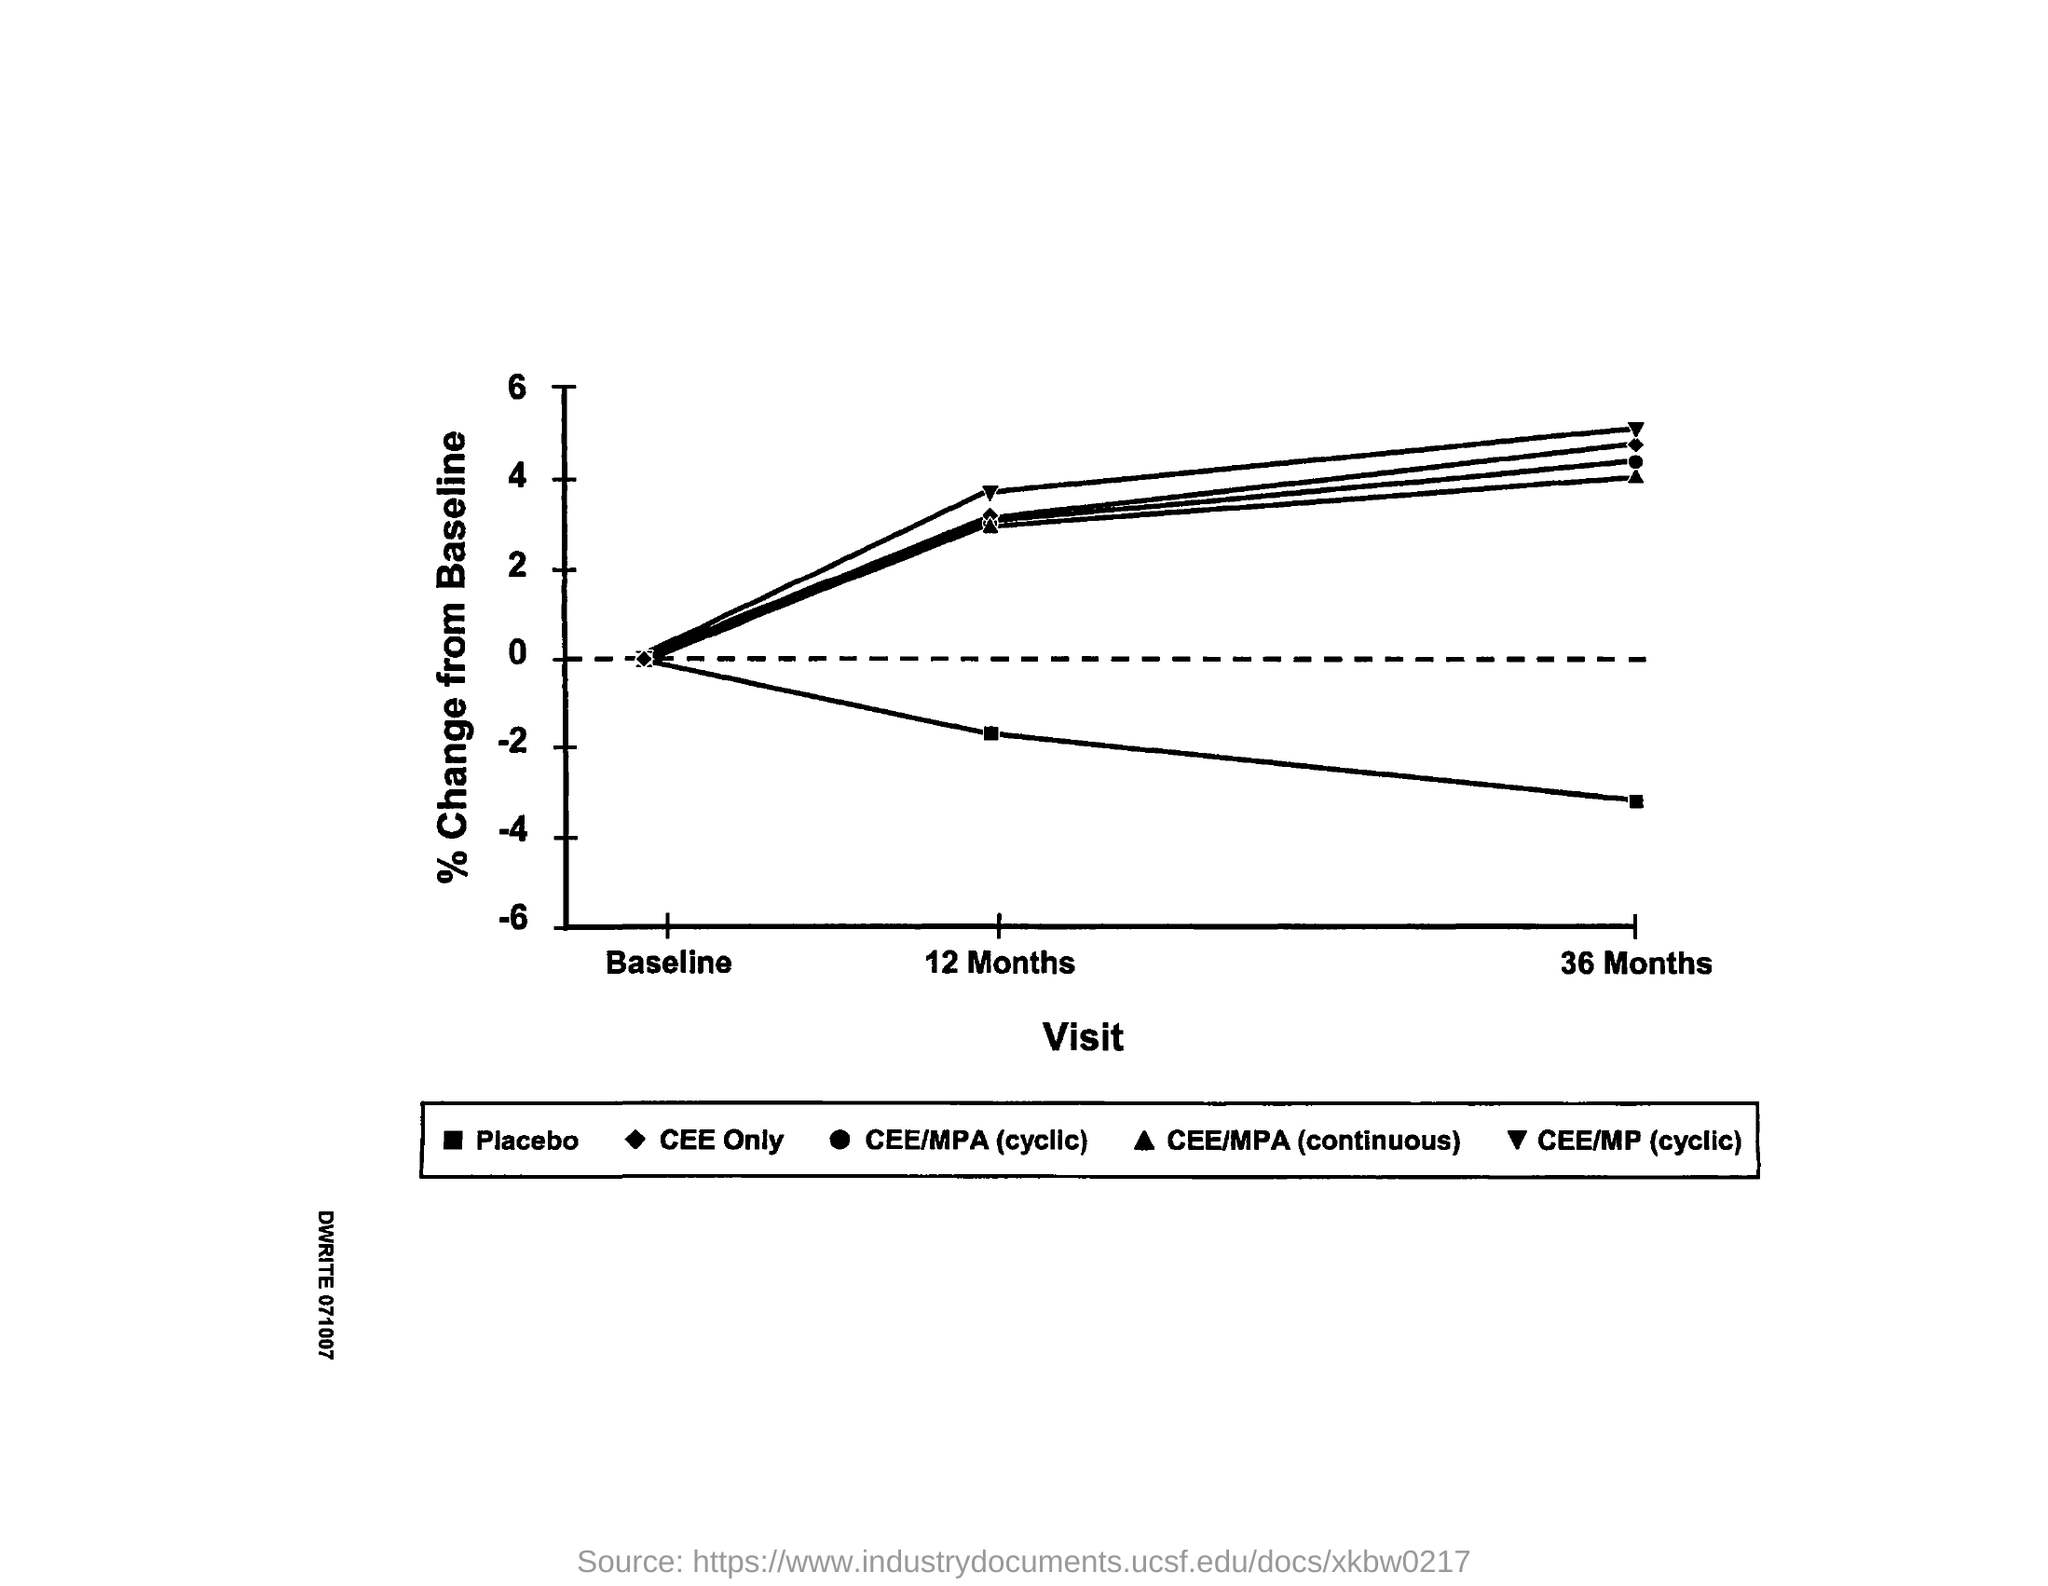Give some essential details in this illustration. The Y-axis represents the percentage change from the baseline value. The X-axis represents the number of visits, with each bar on the axis corresponding to a specific number of visits. 